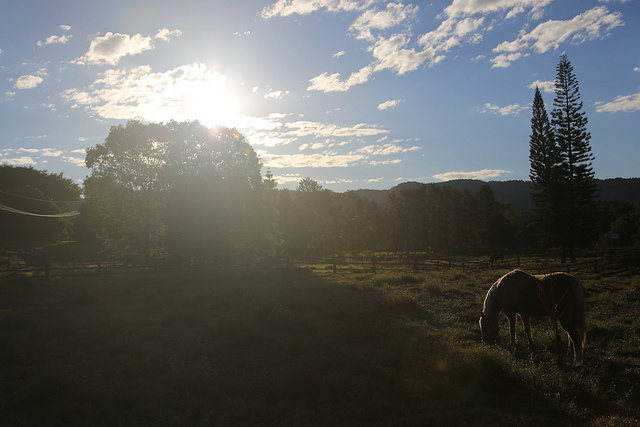How many of the train cars can you see someone sticking their head out of? 0 